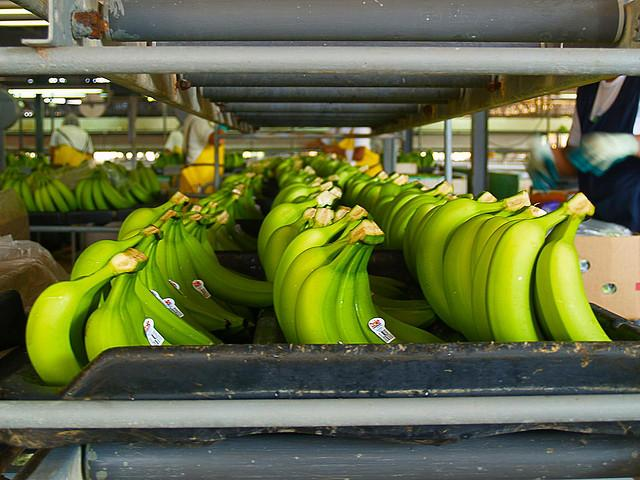Which food company produces these bananas? dole 